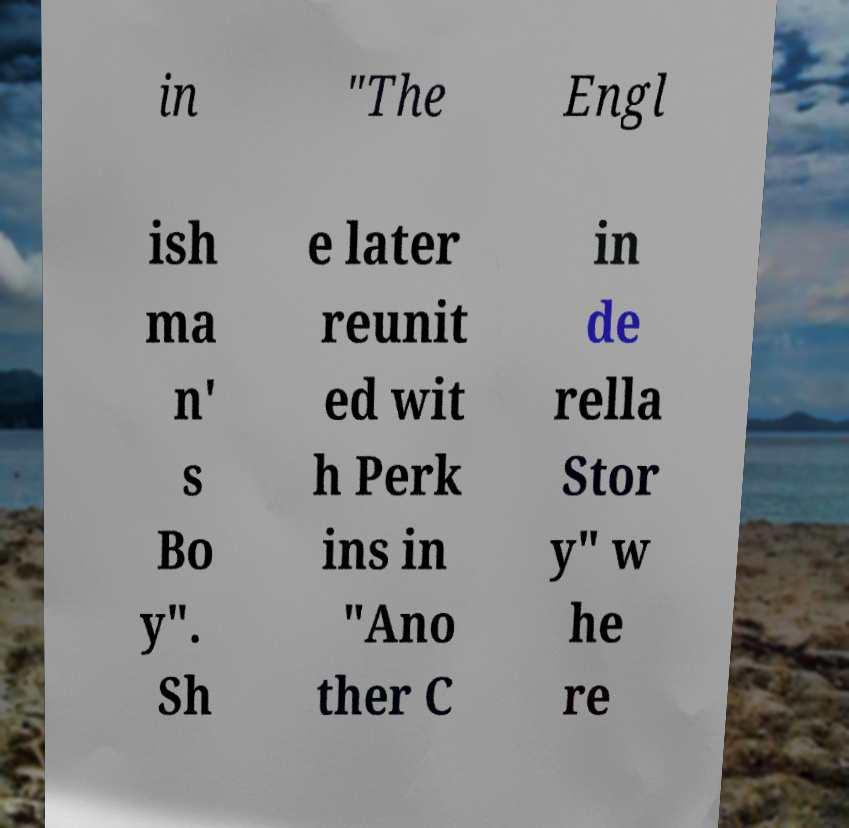Could you extract and type out the text from this image? in "The Engl ish ma n' s Bo y". Sh e later reunit ed wit h Perk ins in "Ano ther C in de rella Stor y" w he re 